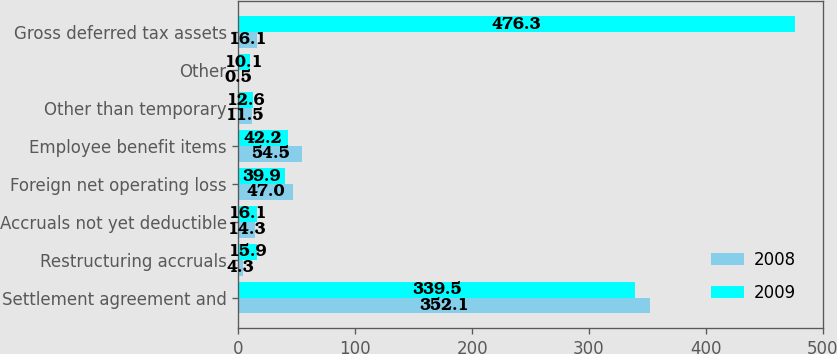Convert chart to OTSL. <chart><loc_0><loc_0><loc_500><loc_500><stacked_bar_chart><ecel><fcel>Settlement agreement and<fcel>Restructuring accruals<fcel>Accruals not yet deductible<fcel>Foreign net operating loss<fcel>Employee benefit items<fcel>Other than temporary<fcel>Other<fcel>Gross deferred tax assets<nl><fcel>2008<fcel>352.1<fcel>4.3<fcel>14.3<fcel>47<fcel>54.5<fcel>11.5<fcel>0.5<fcel>16.1<nl><fcel>2009<fcel>339.5<fcel>15.9<fcel>16.1<fcel>39.9<fcel>42.2<fcel>12.6<fcel>10.1<fcel>476.3<nl></chart> 